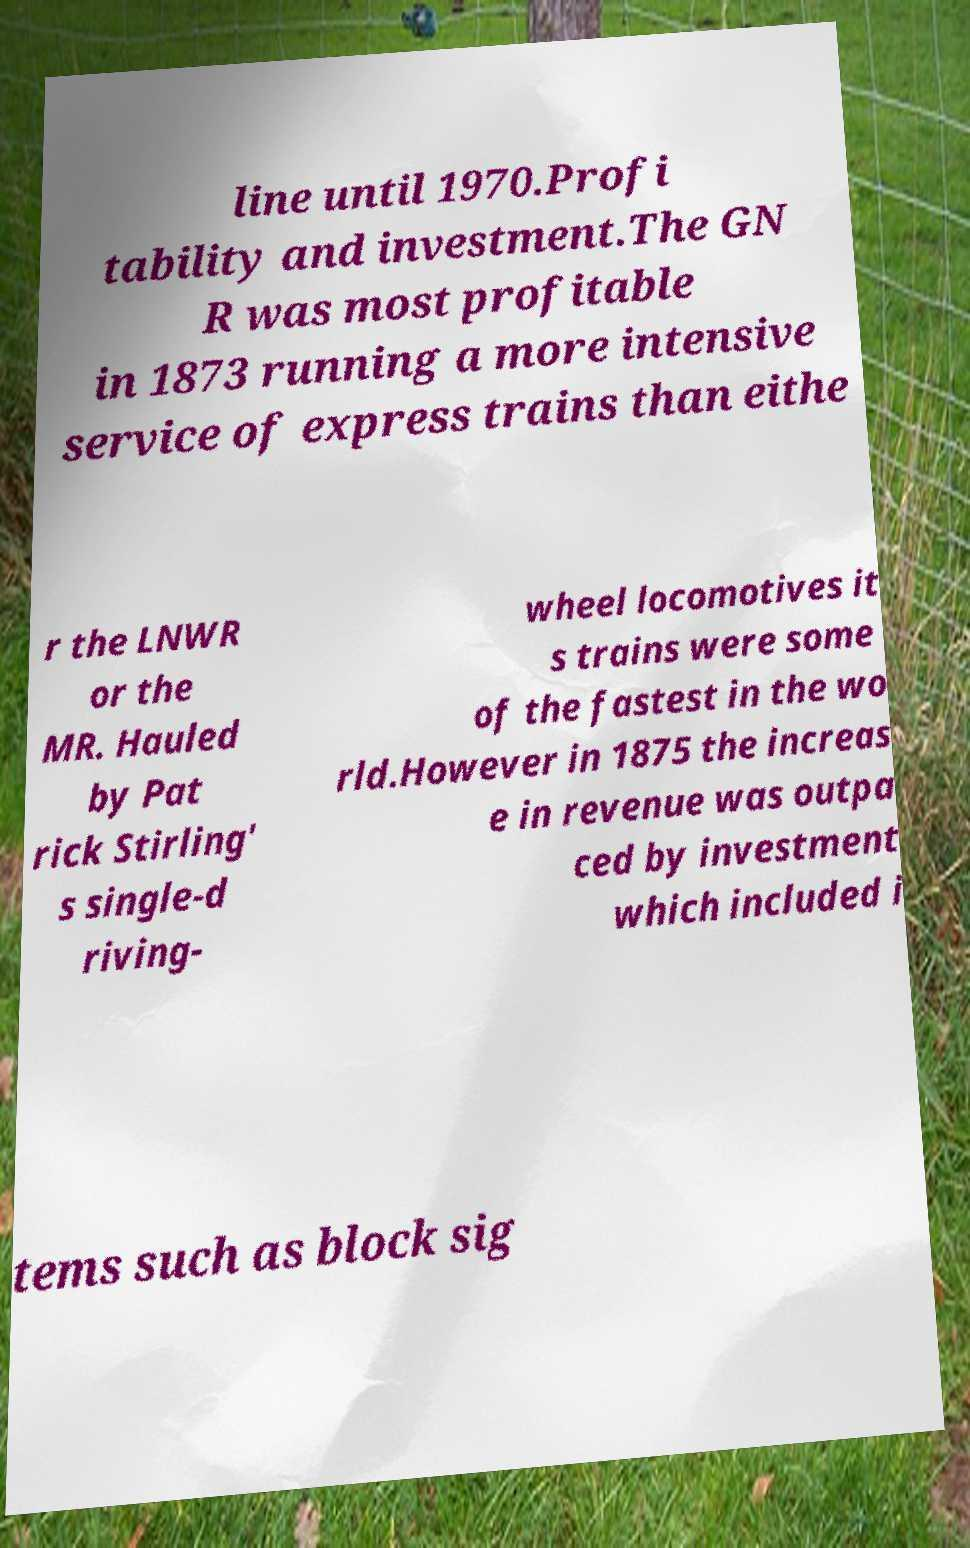For documentation purposes, I need the text within this image transcribed. Could you provide that? line until 1970.Profi tability and investment.The GN R was most profitable in 1873 running a more intensive service of express trains than eithe r the LNWR or the MR. Hauled by Pat rick Stirling' s single-d riving- wheel locomotives it s trains were some of the fastest in the wo rld.However in 1875 the increas e in revenue was outpa ced by investment which included i tems such as block sig 